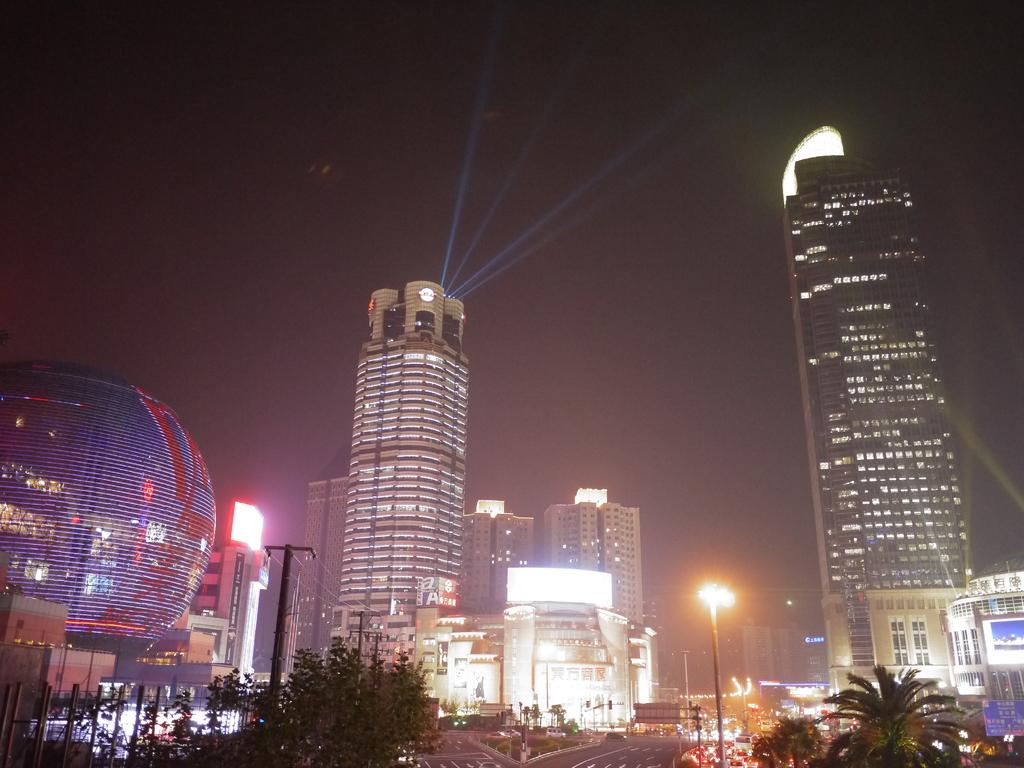What type of structures can be seen in the image? There are buildings in the image. What else can be seen in the image besides buildings? There are poles, wires, lights, a road, trees, and the sky visible in the image. Can you describe the kitten playing with the girl during the rainstorm in the image? There is no kitten, girl, or rainstorm present in the image. 